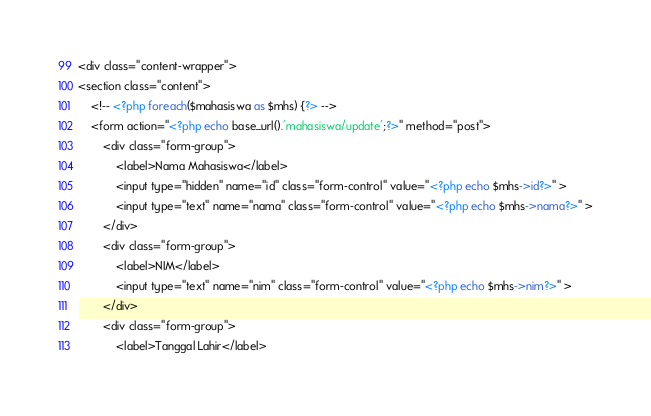Convert code to text. <code><loc_0><loc_0><loc_500><loc_500><_PHP_><div class="content-wrapper">
<section class="content">
    <!-- <?php foreach($mahasiswa as $mhs) {?> -->
    <form action="<?php echo base_url().'mahasiswa/update';?>" method="post">
        <div class="form-group">
            <label>Nama Mahasiswa</label>
            <input type="hidden" name="id" class="form-control" value="<?php echo $mhs->id?>" >
            <input type="text" name="nama" class="form-control" value="<?php echo $mhs->nama?>" >
        </div>
        <div class="form-group">
            <label>NIM</label>
            <input type="text" name="nim" class="form-control" value="<?php echo $mhs->nim?>" >
        </div>
        <div class="form-group">
            <label>Tanggal Lahir</label></code> 